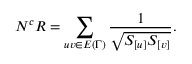<formula> <loc_0><loc_0><loc_500><loc_500>N ^ { c } R = \sum _ { u v \in E { ( \Gamma ) } } \frac { 1 } { \sqrt { S _ { [ u ] } S _ { [ v ] } } } .</formula> 